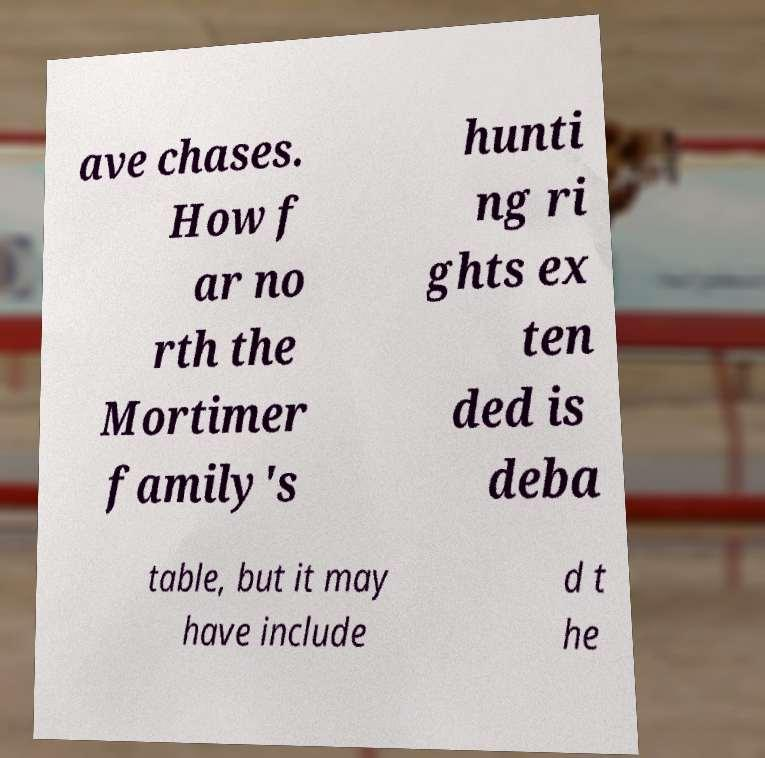Please identify and transcribe the text found in this image. ave chases. How f ar no rth the Mortimer family's hunti ng ri ghts ex ten ded is deba table, but it may have include d t he 